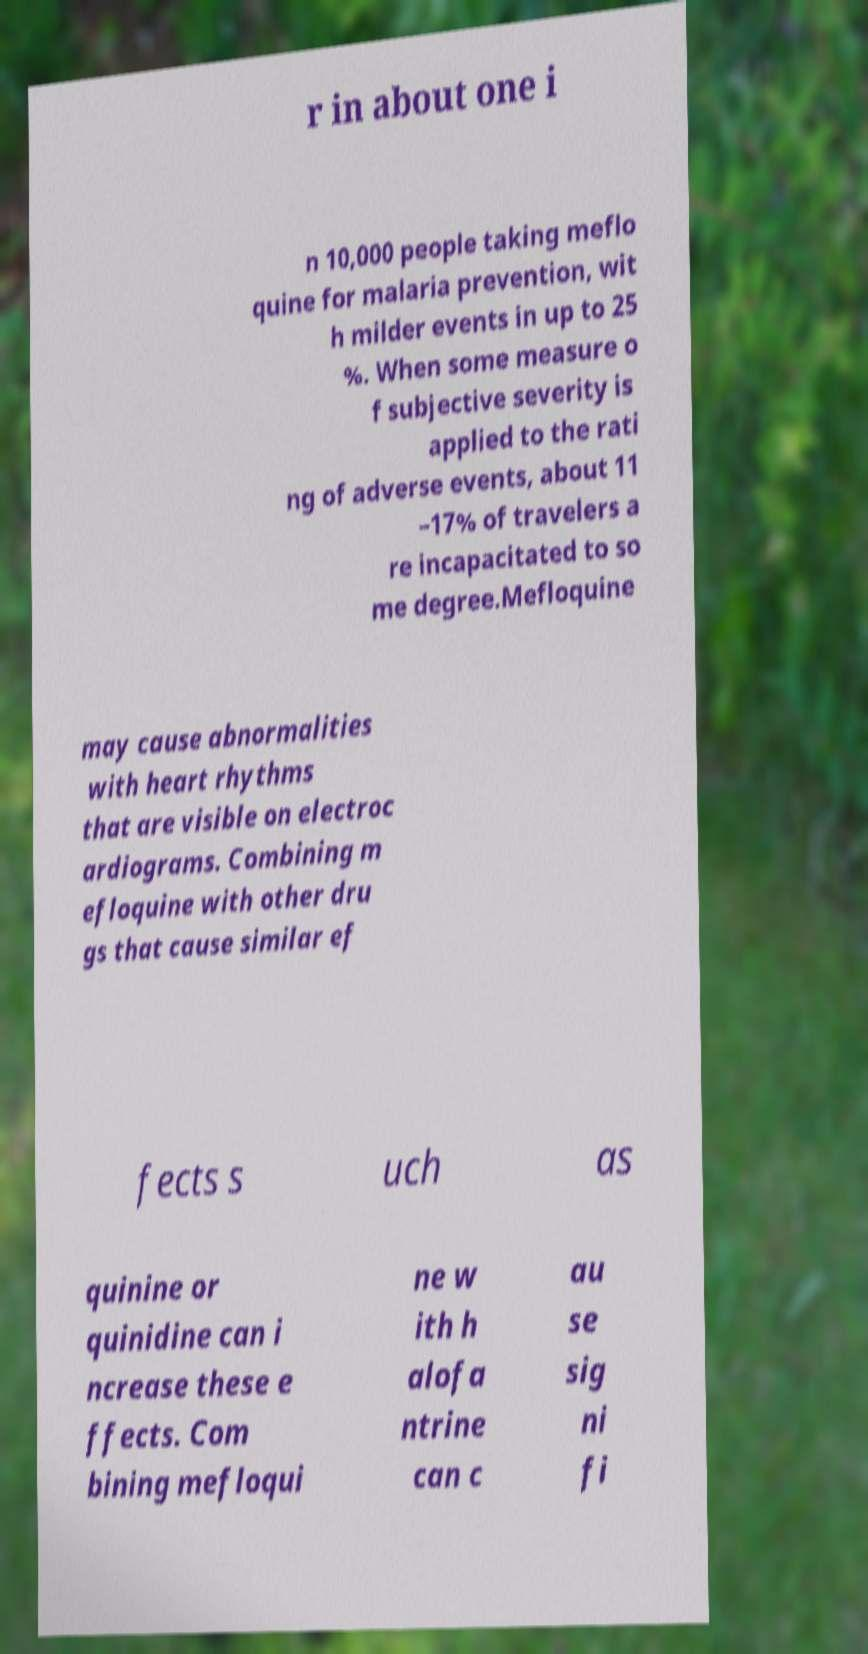Could you assist in decoding the text presented in this image and type it out clearly? r in about one i n 10,000 people taking meflo quine for malaria prevention, wit h milder events in up to 25 %. When some measure o f subjective severity is applied to the rati ng of adverse events, about 11 –17% of travelers a re incapacitated to so me degree.Mefloquine may cause abnormalities with heart rhythms that are visible on electroc ardiograms. Combining m efloquine with other dru gs that cause similar ef fects s uch as quinine or quinidine can i ncrease these e ffects. Com bining mefloqui ne w ith h alofa ntrine can c au se sig ni fi 